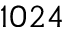Convert formula to latex. <formula><loc_0><loc_0><loc_500><loc_500>1 0 2 4</formula> 